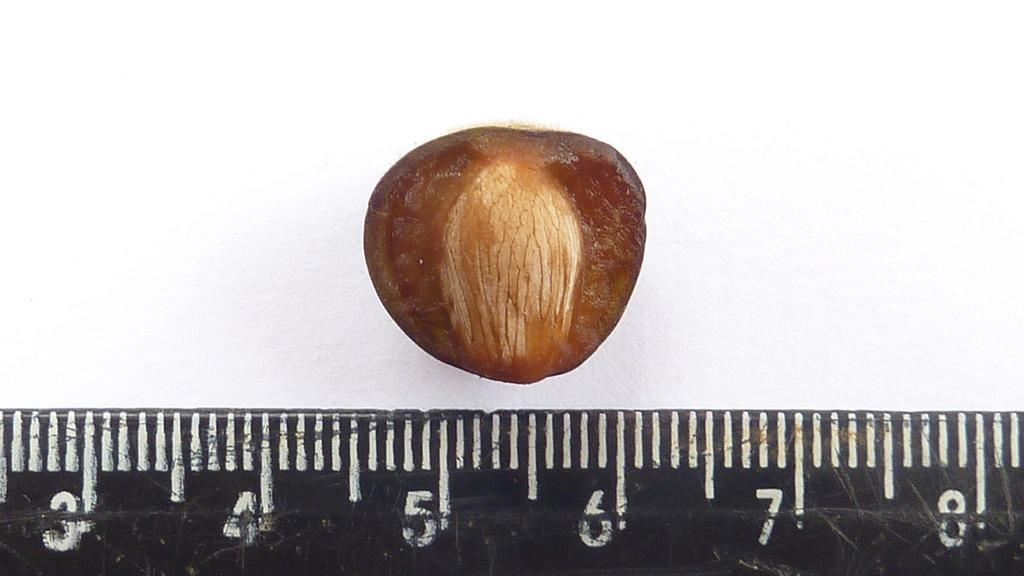<image>
Give a short and clear explanation of the subsequent image. Ruler measuring a piece of nut which is currently on top of the number 5 and 6. 